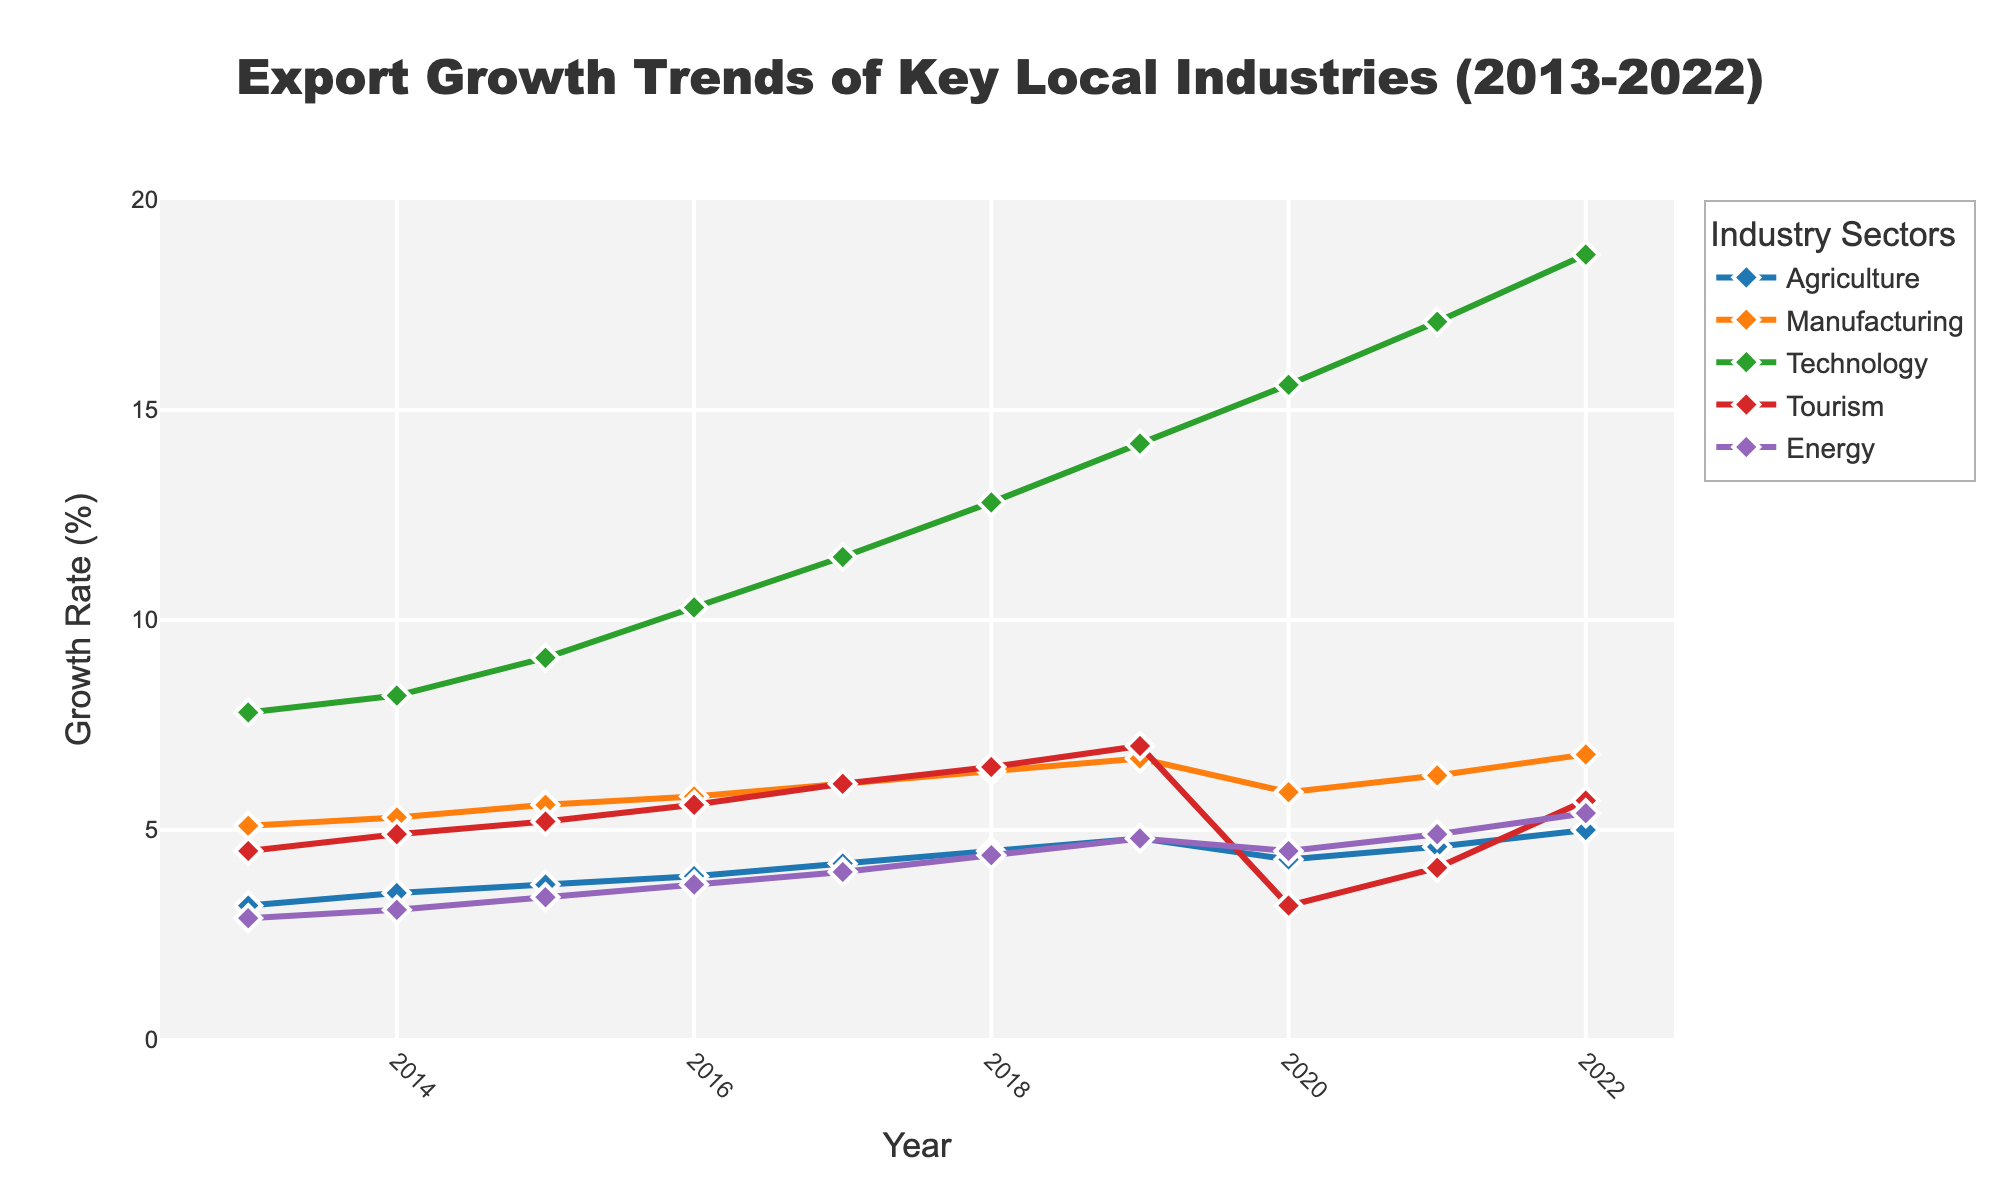what's the overall trend for the Technology sector over the past decade? From 2013 to 2022, look at the data points for Technology. They consistently increase each year, indicating a positive growth trend. The values start at 7.8% in 2013 and rise to 18.7% in 2022.
Answer: Positive growth trend which year showed the highest growth rate in the Energy sector? Check the values in the Energy sector from 2013 to 2022. The highest value is 5.4% in the year 2022.
Answer: 2022 how did Tourism exports change from 2019 to 2020? Compare the Tourism export values for 2019 and 2020. The value dropped from 7.0% in 2019 to 3.2% in 2020.
Answer: Decreased by 3.8% which sectors had their lowest growth in 2020, and what were those rates? Examine the data for 2020. Find the minimum values for each sector. Technology, Tourism, and Manufacturing had some of their lowest points. Specifically, Tourism saw a significant drop to 3.2%, while Technology and Manufacturing had dips as well but were not their lowest.
Answer: Tourism 3.2%, Technology, Manufacturing which sector had the most steadiness in growth rates over the decade? Assess the data trends for each sector from 2013 to 2022. Agriculture shows a steady incremental change from 3.2% to 5.0% without any sudden drops or spikes.
Answer: Agriculture how did the Manufacturing sector perform relative to the Agriculture sector in 2020? Compare the figures for 2020. Manufacturing had a growth rate of 5.9%, and Agriculture had a growth rate of 4.3%. Manufacturing outperformed Agriculture.
Answer: Manufacturing performed better what's the average growth rate for Agriculture over the decade? Sum all the growth rates for Agriculture from 2013 to 2022 and divide by the number of years (10). (3.2 + 3.5 + 3.7 + 3.9 + 4.2 + 4.5 + 4.8 + 4.3 + 4.6 + 5.0) / 10 = 4.17%
Answer: 4.17% which two sectors showed the most growth variability (ups and downs) over the decade? Look for sectors with significant fluctuations year by year. Tourism and Technology show the most variability with noticeable peaks and troughs in their growth rates.
Answer: Tourism, Technology how did the growth rates of Agriculture and Energy compare in 2017? Look at the values for both sectors in 2017. Agriculture was at 4.2% and Energy at 4.0%. Agriculture had a slightly higher growth rate.
Answer: Agriculture higher what is the cumulative growth rate increase for Technology from 2013 to 2022? Subtract the Technology growth rate in 2013 from the rate in 2022: 18.7% - 7.8% = 10.9%
Answer: 10.9% 